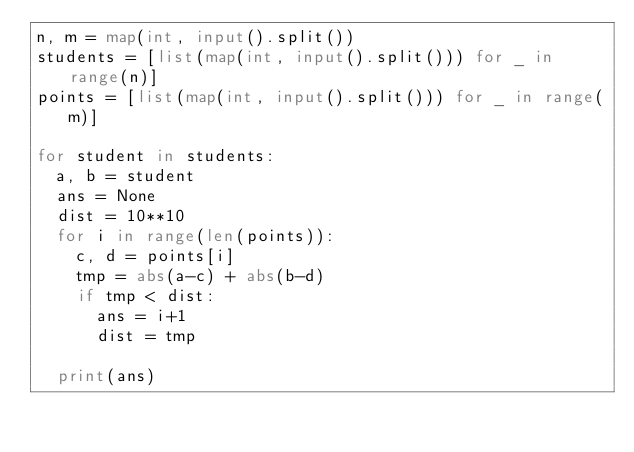<code> <loc_0><loc_0><loc_500><loc_500><_Python_>n, m = map(int, input().split())
students = [list(map(int, input().split())) for _ in range(n)]
points = [list(map(int, input().split())) for _ in range(m)]

for student in students:
  a, b = student
  ans = None
  dist = 10**10
  for i in range(len(points)):
    c, d = points[i]
    tmp = abs(a-c) + abs(b-d)
    if tmp < dist:
      ans = i+1
      dist = tmp
      
  print(ans)</code> 